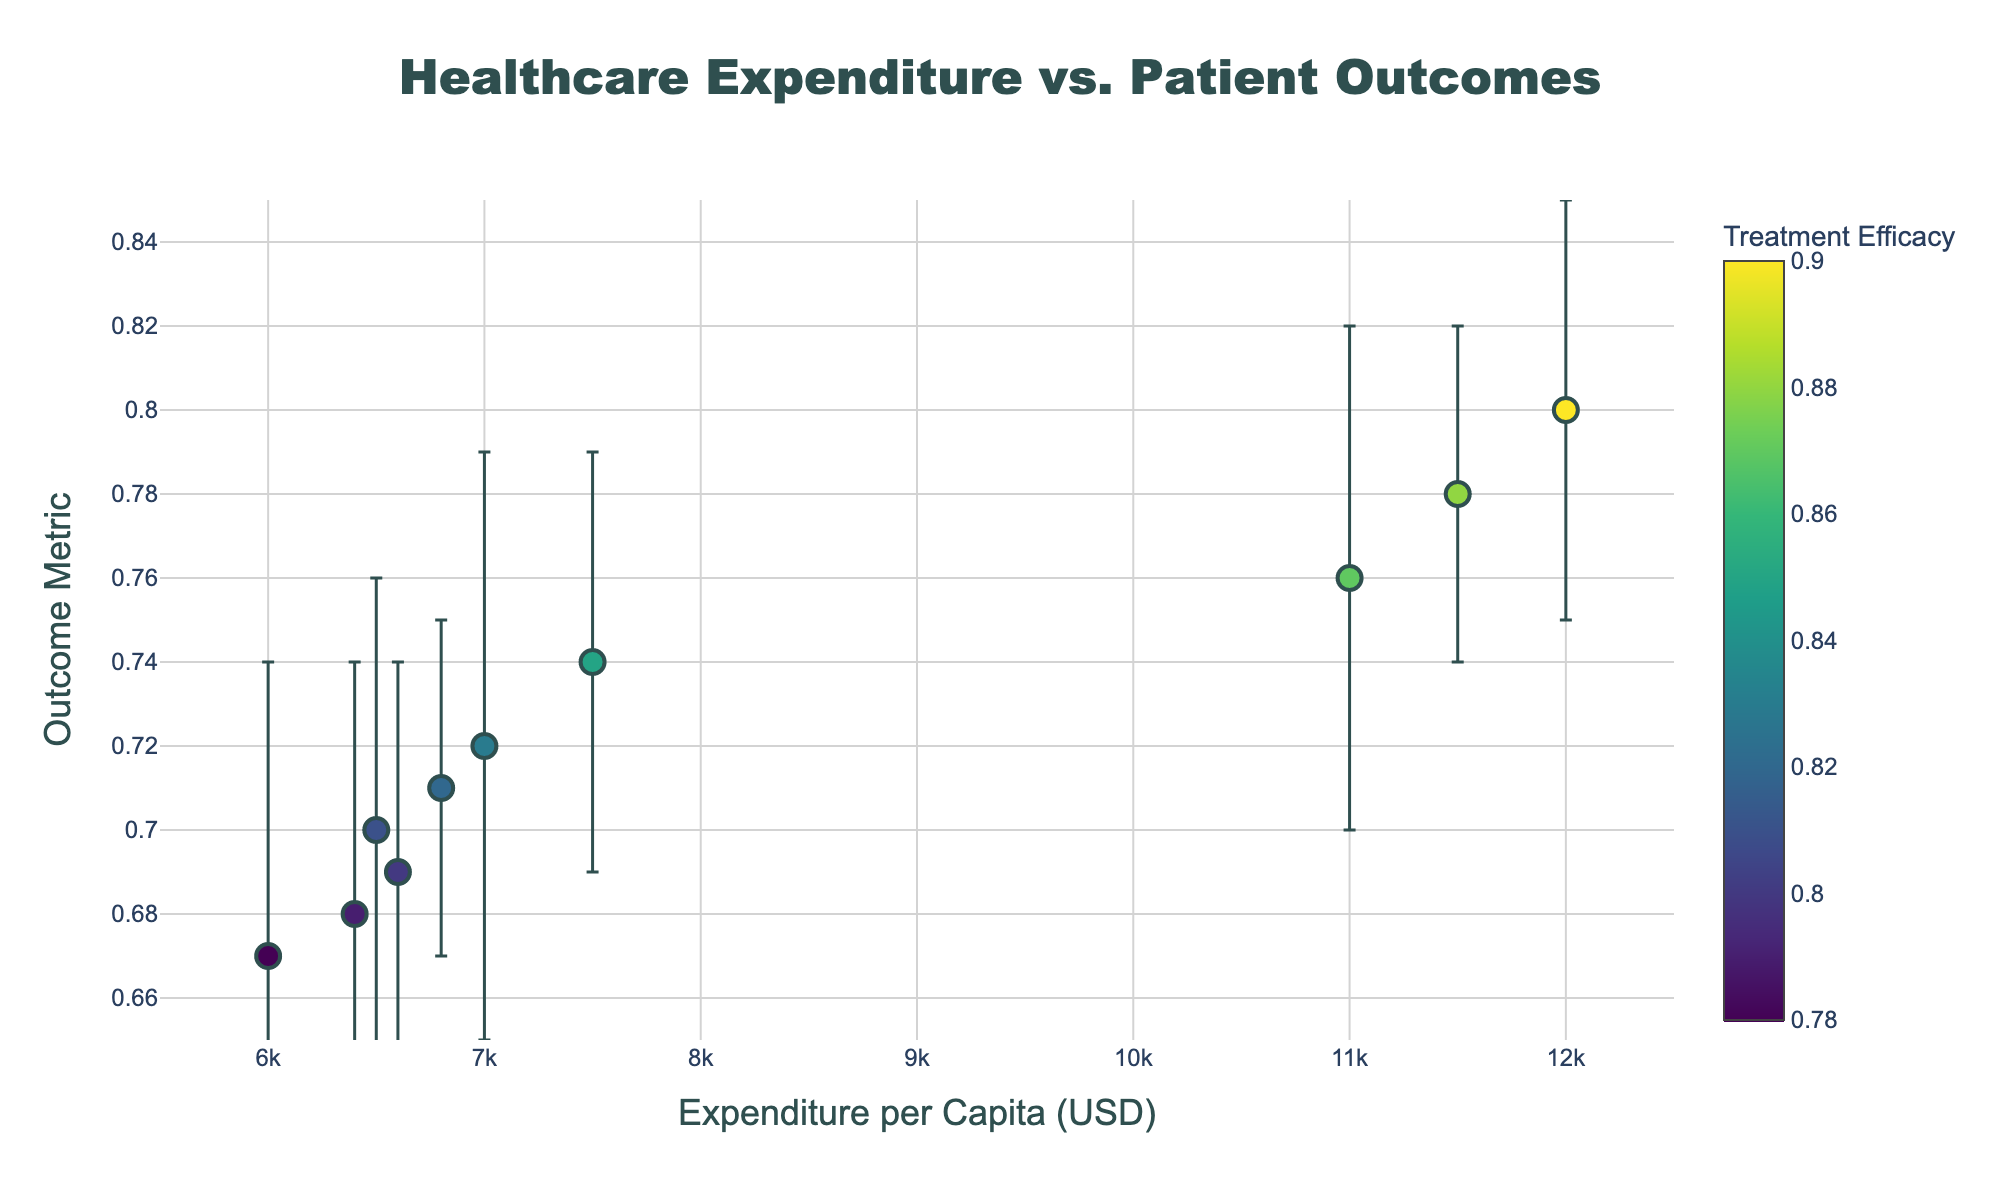How many data points are displayed in the scatter plot? By visually counting the markers (representing healthcare providers) on the scatter plot, we can determine the total number of data points.
Answer: 10 What is the range of the 'Expenditure per Capita' axis? The x-axis of the plot is marked from 5500 to 12500 USD, as indicated on the axis labels.
Answer: 5500 to 12500 USD Which country has the highest 'Outcome Metric'? By identifying the marker corresponding to the highest y-value (Outcome Metric), and hovering over it to see the provider and country information, we can determine it is the Mayo Clinic in the USA.
Answer: USA What is the color range used to show 'Treatment Efficacy'? The color scale displayed alongside the graph extends from around 0.78 (darkest green) to 0.9 (brightest yellow). This can be visually determined by referencing the color bar next to the plot.
Answer: 0.78 to 0.9 Which healthcare provider has the largest 'Outcome Metric' error bar? By comparing the vertical lengths of the error bars, the marker with the largest error bar belongs to Karolinska University Hospital, indicated by hovering over the markers and reading the provider information.
Answer: Karolinska University Hospital Compare the 'Expenditure per Capita' and 'Outcome Metric' of Charité - Universitätsmedizin Berlin and Royal Melbourne Hospital. Charité - Universitätsmedizin Berlin has an expenditure of $7500 and an outcome metric of 0.74, while Royal Melbourne Hospital has an expenditure of $6600 and an outcome metric of 0.69. By comparing these pairs of values, we assess how they relate to each other.
Answer: Charité: 7500, 0.74; Royal Melbourne: 6600, 0.69 Which healthcare provider has the best combination of high 'Outcome Metric' and high 'Treatment Efficacy'? By looking at the upper right region of the scatter plot, which represents high outcome metrics and high treatment efficacies (as shown by color intensity), we identify the Mayo Clinic.
Answer: Mayo Clinic What is the 'Outcome Metric' range covered by the error bar for Aarhus University Hospital? The outcome metric for Aarhus University Hospital is 0.71 with an error of ±0.04. Therefore, the range is from 0.67 to 0.75.
Answer: 0.67 to 0.75 Which country has the lowest 'Expenditure per Capita'? Hovering over the markers to identify countries and checking the x-axis values, we find that Israel, represented by Sheba Medical Center, has the lowest expenditure at $6000 per capita.
Answer: Israel 